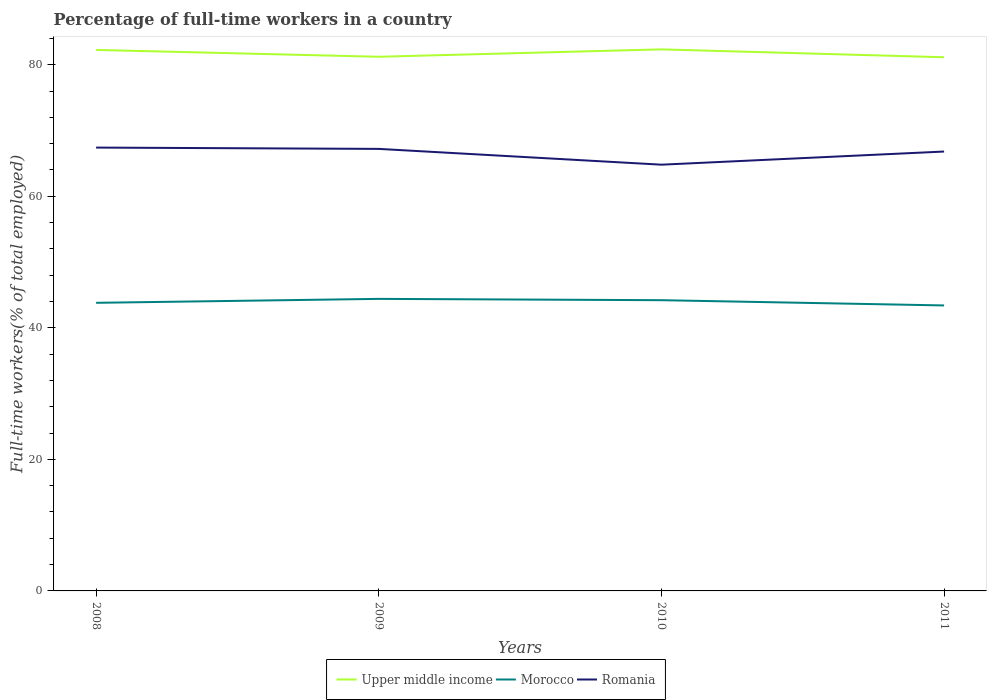Does the line corresponding to Romania intersect with the line corresponding to Upper middle income?
Your answer should be compact. No. Across all years, what is the maximum percentage of full-time workers in Morocco?
Offer a terse response. 43.4. In which year was the percentage of full-time workers in Upper middle income maximum?
Ensure brevity in your answer.  2011. What is the total percentage of full-time workers in Morocco in the graph?
Keep it short and to the point. -0.4. What is the difference between the highest and the second highest percentage of full-time workers in Upper middle income?
Provide a succinct answer. 1.2. Is the percentage of full-time workers in Romania strictly greater than the percentage of full-time workers in Upper middle income over the years?
Provide a short and direct response. Yes. How many lines are there?
Your answer should be compact. 3. How many years are there in the graph?
Your answer should be compact. 4. Does the graph contain any zero values?
Ensure brevity in your answer.  No. Does the graph contain grids?
Offer a very short reply. No. How many legend labels are there?
Give a very brief answer. 3. What is the title of the graph?
Your answer should be compact. Percentage of full-time workers in a country. Does "Israel" appear as one of the legend labels in the graph?
Provide a short and direct response. No. What is the label or title of the X-axis?
Keep it short and to the point. Years. What is the label or title of the Y-axis?
Your response must be concise. Full-time workers(% of total employed). What is the Full-time workers(% of total employed) of Upper middle income in 2008?
Your response must be concise. 82.24. What is the Full-time workers(% of total employed) of Morocco in 2008?
Ensure brevity in your answer.  43.8. What is the Full-time workers(% of total employed) in Romania in 2008?
Your answer should be compact. 67.4. What is the Full-time workers(% of total employed) in Upper middle income in 2009?
Offer a very short reply. 81.21. What is the Full-time workers(% of total employed) of Morocco in 2009?
Ensure brevity in your answer.  44.4. What is the Full-time workers(% of total employed) in Romania in 2009?
Keep it short and to the point. 67.2. What is the Full-time workers(% of total employed) of Upper middle income in 2010?
Offer a very short reply. 82.33. What is the Full-time workers(% of total employed) of Morocco in 2010?
Ensure brevity in your answer.  44.2. What is the Full-time workers(% of total employed) in Romania in 2010?
Offer a terse response. 64.8. What is the Full-time workers(% of total employed) of Upper middle income in 2011?
Keep it short and to the point. 81.13. What is the Full-time workers(% of total employed) of Morocco in 2011?
Give a very brief answer. 43.4. What is the Full-time workers(% of total employed) of Romania in 2011?
Provide a short and direct response. 66.8. Across all years, what is the maximum Full-time workers(% of total employed) of Upper middle income?
Your answer should be very brief. 82.33. Across all years, what is the maximum Full-time workers(% of total employed) of Morocco?
Your response must be concise. 44.4. Across all years, what is the maximum Full-time workers(% of total employed) of Romania?
Give a very brief answer. 67.4. Across all years, what is the minimum Full-time workers(% of total employed) in Upper middle income?
Your response must be concise. 81.13. Across all years, what is the minimum Full-time workers(% of total employed) of Morocco?
Provide a short and direct response. 43.4. Across all years, what is the minimum Full-time workers(% of total employed) in Romania?
Give a very brief answer. 64.8. What is the total Full-time workers(% of total employed) in Upper middle income in the graph?
Make the answer very short. 326.91. What is the total Full-time workers(% of total employed) of Morocco in the graph?
Ensure brevity in your answer.  175.8. What is the total Full-time workers(% of total employed) in Romania in the graph?
Your answer should be compact. 266.2. What is the difference between the Full-time workers(% of total employed) of Upper middle income in 2008 and that in 2009?
Offer a very short reply. 1.04. What is the difference between the Full-time workers(% of total employed) of Upper middle income in 2008 and that in 2010?
Ensure brevity in your answer.  -0.08. What is the difference between the Full-time workers(% of total employed) of Morocco in 2008 and that in 2010?
Give a very brief answer. -0.4. What is the difference between the Full-time workers(% of total employed) in Upper middle income in 2008 and that in 2011?
Give a very brief answer. 1.11. What is the difference between the Full-time workers(% of total employed) in Romania in 2008 and that in 2011?
Keep it short and to the point. 0.6. What is the difference between the Full-time workers(% of total employed) in Upper middle income in 2009 and that in 2010?
Make the answer very short. -1.12. What is the difference between the Full-time workers(% of total employed) of Romania in 2009 and that in 2010?
Your response must be concise. 2.4. What is the difference between the Full-time workers(% of total employed) of Upper middle income in 2009 and that in 2011?
Give a very brief answer. 0.07. What is the difference between the Full-time workers(% of total employed) in Morocco in 2009 and that in 2011?
Your answer should be compact. 1. What is the difference between the Full-time workers(% of total employed) in Romania in 2009 and that in 2011?
Make the answer very short. 0.4. What is the difference between the Full-time workers(% of total employed) in Upper middle income in 2010 and that in 2011?
Provide a short and direct response. 1.2. What is the difference between the Full-time workers(% of total employed) in Morocco in 2010 and that in 2011?
Provide a short and direct response. 0.8. What is the difference between the Full-time workers(% of total employed) of Romania in 2010 and that in 2011?
Your answer should be compact. -2. What is the difference between the Full-time workers(% of total employed) of Upper middle income in 2008 and the Full-time workers(% of total employed) of Morocco in 2009?
Ensure brevity in your answer.  37.84. What is the difference between the Full-time workers(% of total employed) in Upper middle income in 2008 and the Full-time workers(% of total employed) in Romania in 2009?
Your answer should be compact. 15.04. What is the difference between the Full-time workers(% of total employed) of Morocco in 2008 and the Full-time workers(% of total employed) of Romania in 2009?
Provide a short and direct response. -23.4. What is the difference between the Full-time workers(% of total employed) in Upper middle income in 2008 and the Full-time workers(% of total employed) in Morocco in 2010?
Offer a very short reply. 38.04. What is the difference between the Full-time workers(% of total employed) in Upper middle income in 2008 and the Full-time workers(% of total employed) in Romania in 2010?
Make the answer very short. 17.44. What is the difference between the Full-time workers(% of total employed) in Upper middle income in 2008 and the Full-time workers(% of total employed) in Morocco in 2011?
Your answer should be compact. 38.84. What is the difference between the Full-time workers(% of total employed) of Upper middle income in 2008 and the Full-time workers(% of total employed) of Romania in 2011?
Give a very brief answer. 15.44. What is the difference between the Full-time workers(% of total employed) of Morocco in 2008 and the Full-time workers(% of total employed) of Romania in 2011?
Your response must be concise. -23. What is the difference between the Full-time workers(% of total employed) in Upper middle income in 2009 and the Full-time workers(% of total employed) in Morocco in 2010?
Make the answer very short. 37.01. What is the difference between the Full-time workers(% of total employed) of Upper middle income in 2009 and the Full-time workers(% of total employed) of Romania in 2010?
Give a very brief answer. 16.41. What is the difference between the Full-time workers(% of total employed) of Morocco in 2009 and the Full-time workers(% of total employed) of Romania in 2010?
Give a very brief answer. -20.4. What is the difference between the Full-time workers(% of total employed) in Upper middle income in 2009 and the Full-time workers(% of total employed) in Morocco in 2011?
Keep it short and to the point. 37.81. What is the difference between the Full-time workers(% of total employed) of Upper middle income in 2009 and the Full-time workers(% of total employed) of Romania in 2011?
Offer a very short reply. 14.41. What is the difference between the Full-time workers(% of total employed) of Morocco in 2009 and the Full-time workers(% of total employed) of Romania in 2011?
Your answer should be compact. -22.4. What is the difference between the Full-time workers(% of total employed) in Upper middle income in 2010 and the Full-time workers(% of total employed) in Morocco in 2011?
Give a very brief answer. 38.93. What is the difference between the Full-time workers(% of total employed) of Upper middle income in 2010 and the Full-time workers(% of total employed) of Romania in 2011?
Offer a terse response. 15.53. What is the difference between the Full-time workers(% of total employed) in Morocco in 2010 and the Full-time workers(% of total employed) in Romania in 2011?
Provide a short and direct response. -22.6. What is the average Full-time workers(% of total employed) of Upper middle income per year?
Your answer should be very brief. 81.73. What is the average Full-time workers(% of total employed) in Morocco per year?
Provide a short and direct response. 43.95. What is the average Full-time workers(% of total employed) in Romania per year?
Ensure brevity in your answer.  66.55. In the year 2008, what is the difference between the Full-time workers(% of total employed) of Upper middle income and Full-time workers(% of total employed) of Morocco?
Give a very brief answer. 38.44. In the year 2008, what is the difference between the Full-time workers(% of total employed) of Upper middle income and Full-time workers(% of total employed) of Romania?
Provide a succinct answer. 14.84. In the year 2008, what is the difference between the Full-time workers(% of total employed) of Morocco and Full-time workers(% of total employed) of Romania?
Provide a succinct answer. -23.6. In the year 2009, what is the difference between the Full-time workers(% of total employed) of Upper middle income and Full-time workers(% of total employed) of Morocco?
Offer a terse response. 36.81. In the year 2009, what is the difference between the Full-time workers(% of total employed) of Upper middle income and Full-time workers(% of total employed) of Romania?
Provide a short and direct response. 14.01. In the year 2009, what is the difference between the Full-time workers(% of total employed) in Morocco and Full-time workers(% of total employed) in Romania?
Your answer should be very brief. -22.8. In the year 2010, what is the difference between the Full-time workers(% of total employed) in Upper middle income and Full-time workers(% of total employed) in Morocco?
Provide a succinct answer. 38.13. In the year 2010, what is the difference between the Full-time workers(% of total employed) in Upper middle income and Full-time workers(% of total employed) in Romania?
Make the answer very short. 17.53. In the year 2010, what is the difference between the Full-time workers(% of total employed) in Morocco and Full-time workers(% of total employed) in Romania?
Keep it short and to the point. -20.6. In the year 2011, what is the difference between the Full-time workers(% of total employed) in Upper middle income and Full-time workers(% of total employed) in Morocco?
Your answer should be very brief. 37.73. In the year 2011, what is the difference between the Full-time workers(% of total employed) in Upper middle income and Full-time workers(% of total employed) in Romania?
Provide a succinct answer. 14.33. In the year 2011, what is the difference between the Full-time workers(% of total employed) of Morocco and Full-time workers(% of total employed) of Romania?
Your response must be concise. -23.4. What is the ratio of the Full-time workers(% of total employed) of Upper middle income in 2008 to that in 2009?
Make the answer very short. 1.01. What is the ratio of the Full-time workers(% of total employed) of Morocco in 2008 to that in 2009?
Ensure brevity in your answer.  0.99. What is the ratio of the Full-time workers(% of total employed) of Romania in 2008 to that in 2010?
Your answer should be compact. 1.04. What is the ratio of the Full-time workers(% of total employed) in Upper middle income in 2008 to that in 2011?
Ensure brevity in your answer.  1.01. What is the ratio of the Full-time workers(% of total employed) in Morocco in 2008 to that in 2011?
Provide a short and direct response. 1.01. What is the ratio of the Full-time workers(% of total employed) of Romania in 2008 to that in 2011?
Provide a short and direct response. 1.01. What is the ratio of the Full-time workers(% of total employed) in Upper middle income in 2009 to that in 2010?
Offer a very short reply. 0.99. What is the ratio of the Full-time workers(% of total employed) of Morocco in 2009 to that in 2010?
Provide a succinct answer. 1. What is the ratio of the Full-time workers(% of total employed) in Romania in 2009 to that in 2010?
Offer a terse response. 1.04. What is the ratio of the Full-time workers(% of total employed) of Upper middle income in 2009 to that in 2011?
Offer a very short reply. 1. What is the ratio of the Full-time workers(% of total employed) of Upper middle income in 2010 to that in 2011?
Keep it short and to the point. 1.01. What is the ratio of the Full-time workers(% of total employed) in Morocco in 2010 to that in 2011?
Offer a terse response. 1.02. What is the ratio of the Full-time workers(% of total employed) in Romania in 2010 to that in 2011?
Make the answer very short. 0.97. What is the difference between the highest and the second highest Full-time workers(% of total employed) of Upper middle income?
Your response must be concise. 0.08. What is the difference between the highest and the second highest Full-time workers(% of total employed) in Morocco?
Provide a succinct answer. 0.2. What is the difference between the highest and the lowest Full-time workers(% of total employed) of Upper middle income?
Provide a short and direct response. 1.2. What is the difference between the highest and the lowest Full-time workers(% of total employed) in Romania?
Provide a succinct answer. 2.6. 